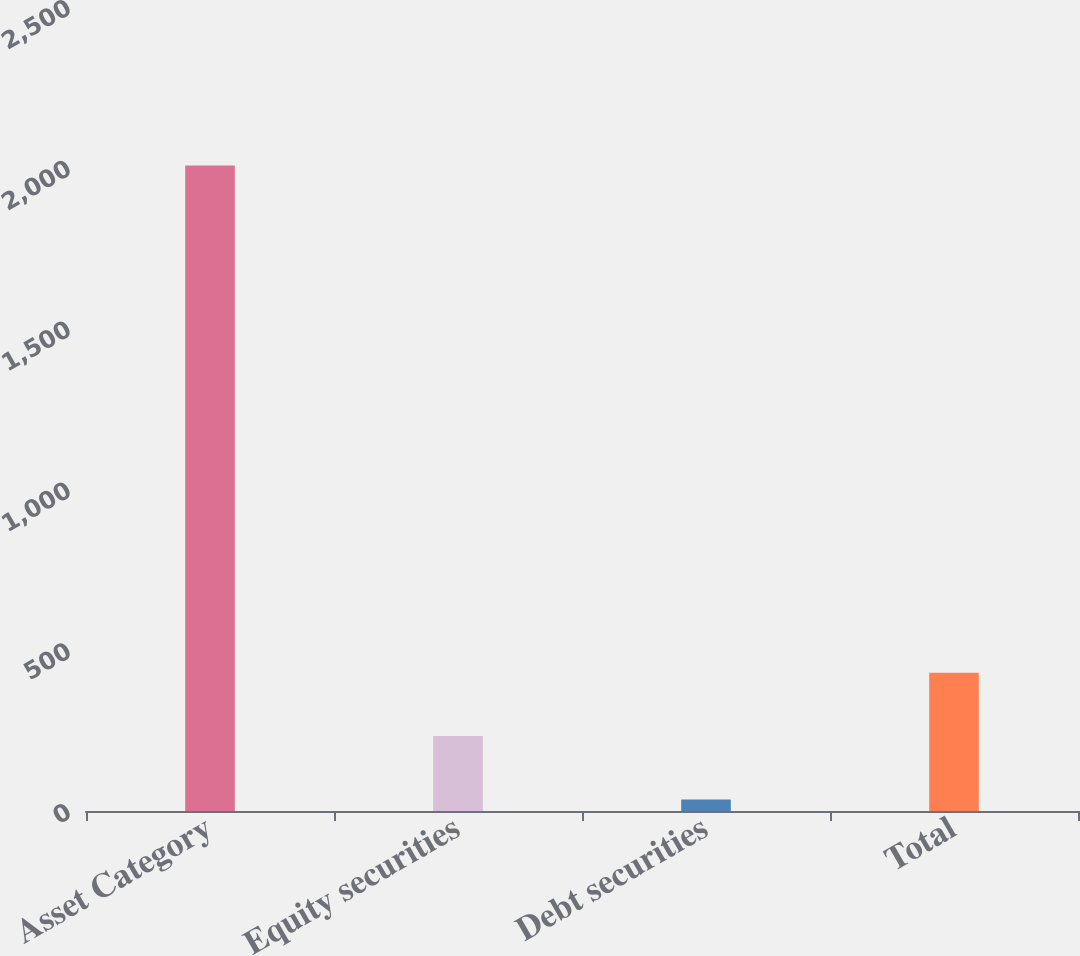Convert chart to OTSL. <chart><loc_0><loc_0><loc_500><loc_500><bar_chart><fcel>Asset Category<fcel>Equity securities<fcel>Debt securities<fcel>Total<nl><fcel>2007<fcel>233.1<fcel>36<fcel>430.2<nl></chart> 